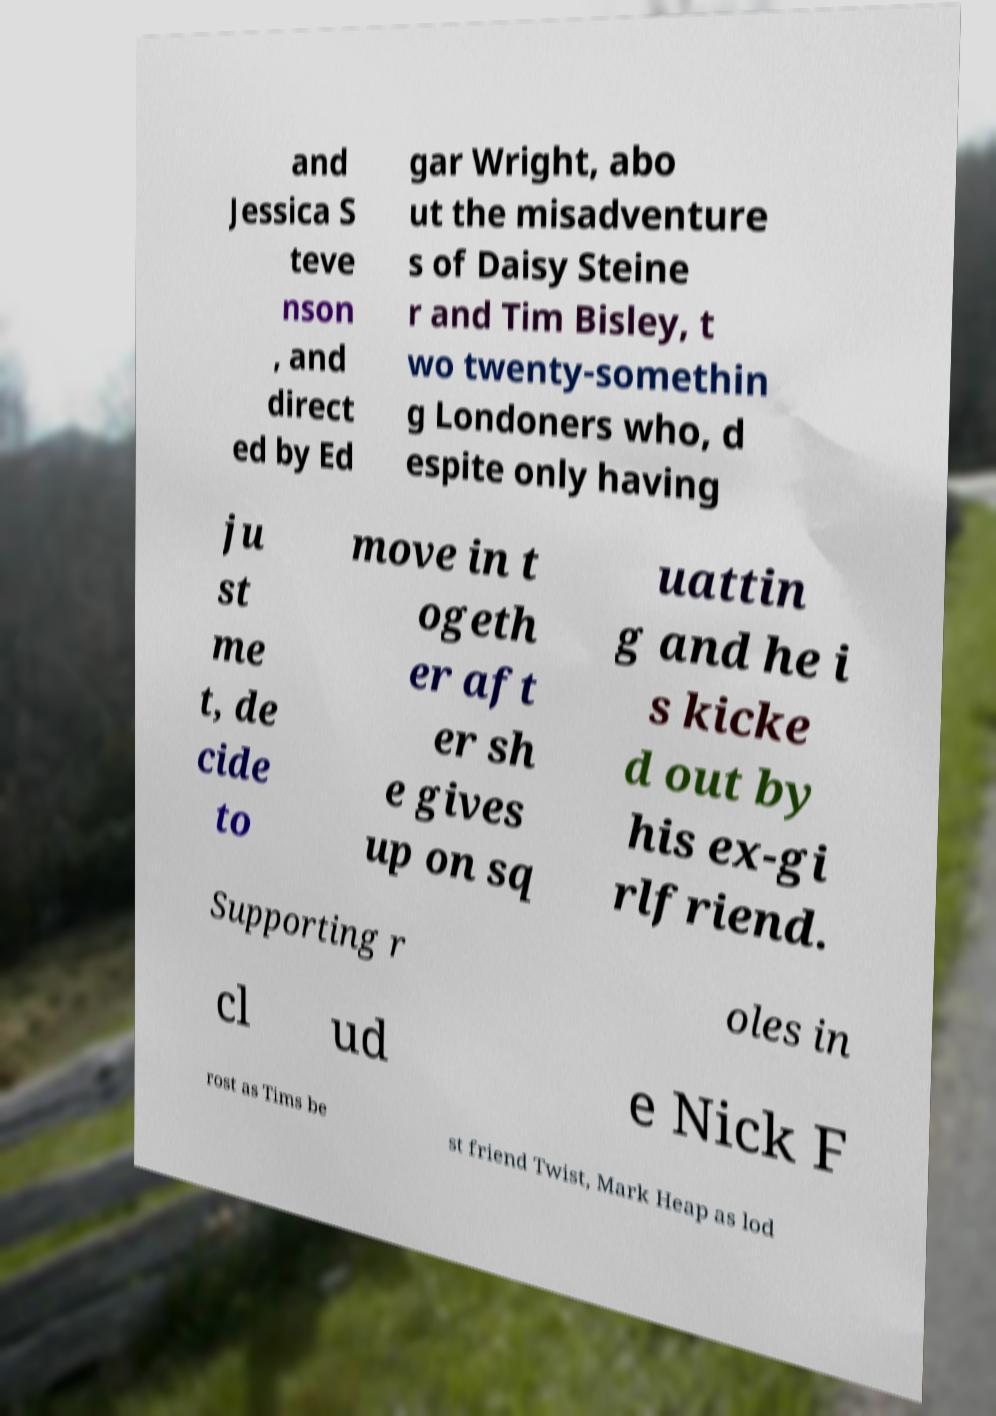Could you extract and type out the text from this image? and Jessica S teve nson , and direct ed by Ed gar Wright, abo ut the misadventure s of Daisy Steine r and Tim Bisley, t wo twenty-somethin g Londoners who, d espite only having ju st me t, de cide to move in t ogeth er aft er sh e gives up on sq uattin g and he i s kicke d out by his ex-gi rlfriend. Supporting r oles in cl ud e Nick F rost as Tims be st friend Twist, Mark Heap as lod 